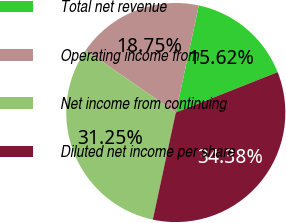<chart> <loc_0><loc_0><loc_500><loc_500><pie_chart><fcel>Total net revenue<fcel>Operating income from<fcel>Net income from continuing<fcel>Diluted net income per share<nl><fcel>15.62%<fcel>18.75%<fcel>31.25%<fcel>34.38%<nl></chart> 